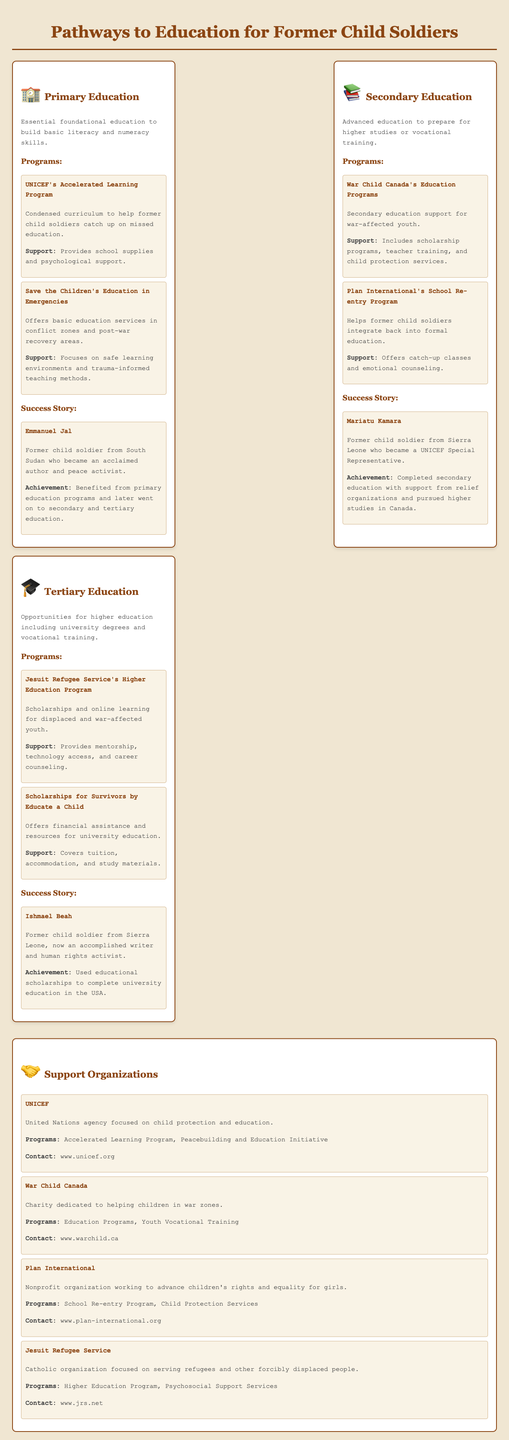What is the first educational pathway for former child soldiers? The first educational pathway is Primary Education, which focuses on foundational skills like literacy and numeracy.
Answer: Primary Education Which program helps catch up on missed education at the primary level? The program that helps is UNICEF's Accelerated Learning Program, which provides a condensed curriculum.
Answer: UNICEF's Accelerated Learning Program Who is the success story highlighted in the primary education section? The success story highlighted is Emmanuel Jal, who became an acclaimed author and peace activist.
Answer: Emmanuel Jal What type of education does the secondary level prepare for? The secondary level prepares for higher studies or vocational training.
Answer: Higher studies or vocational training Which organization focuses on secondary education support for war-affected youth? The organization that focuses on this is War Child Canada.
Answer: War Child Canada What does the Jesuit Refugee Service's Higher Education Program provide? It provides scholarships and online learning for displaced and war-affected youth.
Answer: Scholarships and online learning What is the contact website for War Child Canada? The contact website for War Child Canada is www.warchild.ca.
Answer: www.warchild.ca Which success story was noted in the tertiary education section? The success story noted is Ishmael Beah, an accomplished writer and human rights activist.
Answer: Ishmael Beah What type of support does Plan International's School Re-entry Program provide? The support provided includes catch-up classes and emotional counseling.
Answer: Catch-up classes and emotional counseling What is the key focus of UNICEF as a support organization? UNICEF focuses on child protection and education.
Answer: Child protection and education 